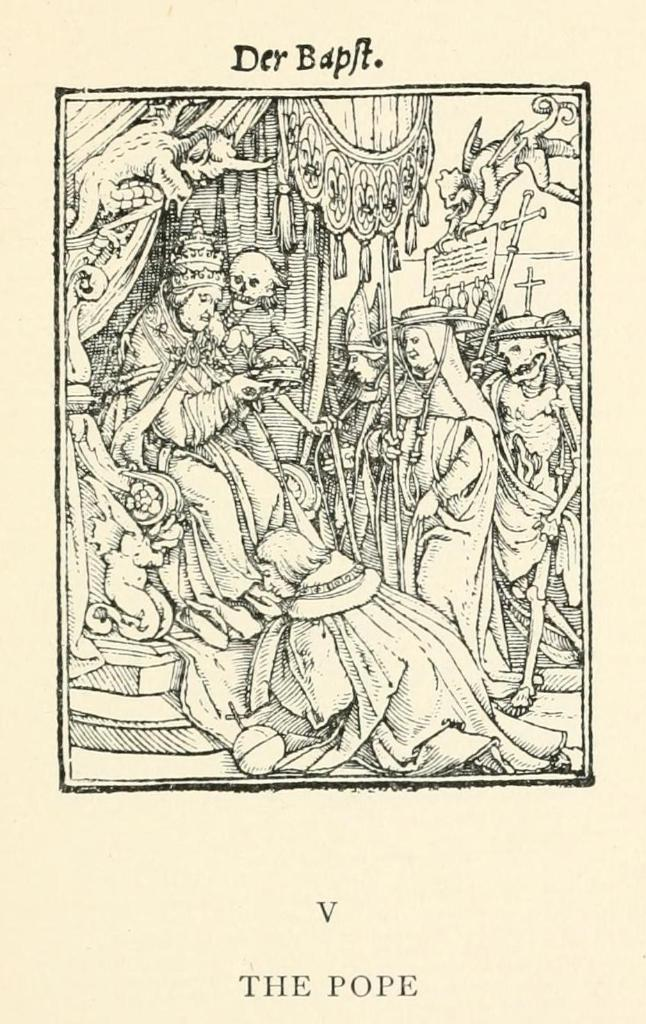What is the main subject of the image? There is a depiction of persons in the image. Are there any words or letters in the image? Yes, there is text present in the image. What type of ship can be seen in the image? There is no ship present in the image; it features a depiction of persons and text. What industry is represented by the persons in the image? The image does not specify any particular industry; it only shows a depiction of persons and text. 